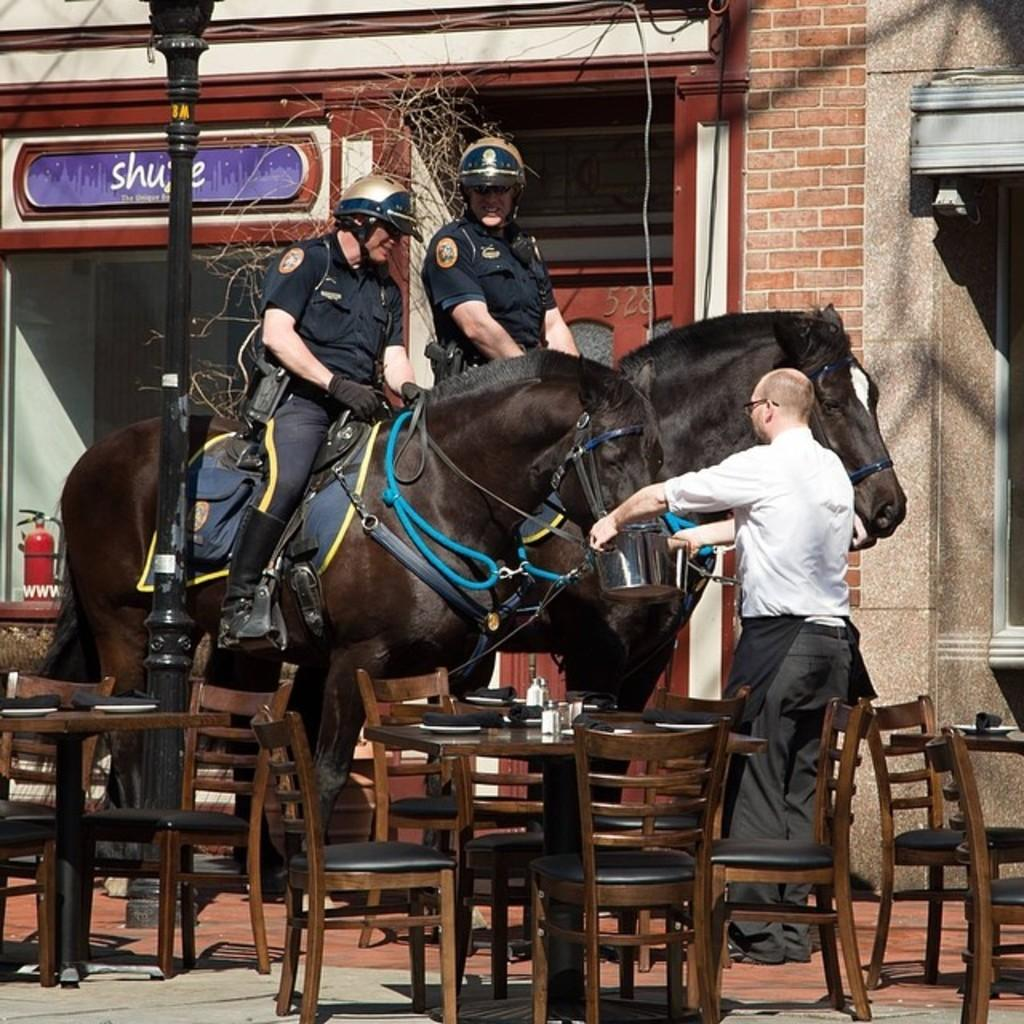How many people are on the horse in the image? There are two people sitting on the horse in the image. What other objects can be seen in the image? Chairs are visible in the image. What is one of the people in the image doing? There is a person feeding the horse. What type of honey can be seen dripping from the bedroom in the image? There is no bedroom or honey present in the image. 